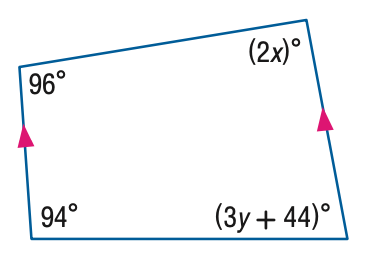Question: Find the value of the variable x in the figure.
Choices:
A. 42
B. 47
C. 48
D. 96
Answer with the letter. Answer: A 